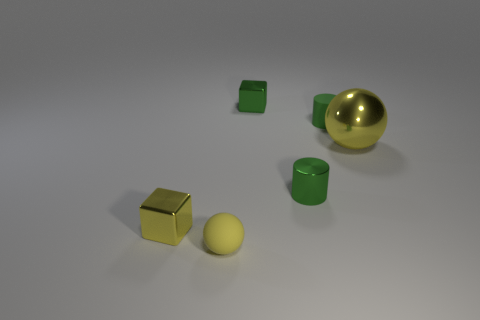What number of green objects are either spheres or matte things?
Offer a terse response. 1. Are the large yellow sphere and the tiny green thing behind the matte cylinder made of the same material?
Your answer should be very brief. Yes. The other object that is the same shape as the large yellow thing is what size?
Offer a very short reply. Small. What material is the small yellow cube?
Offer a terse response. Metal. What is the material of the tiny cube that is on the left side of the yellow ball left of the thing on the right side of the small rubber cylinder?
Your answer should be compact. Metal. Is the size of the yellow ball that is to the left of the rubber cylinder the same as the yellow thing that is on the right side of the yellow matte sphere?
Offer a very short reply. No. How many other objects are the same material as the tiny yellow ball?
Offer a terse response. 1. How many metallic objects are either tiny green objects or spheres?
Your answer should be very brief. 3. Is the number of tiny shiny cylinders less than the number of gray cubes?
Ensure brevity in your answer.  No. There is a yellow shiny cube; does it have the same size as the yellow shiny object that is on the right side of the yellow metal cube?
Your response must be concise. No. 